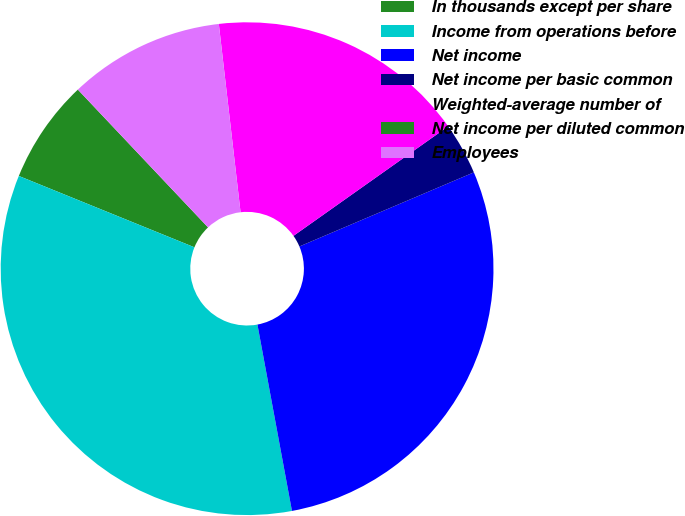<chart> <loc_0><loc_0><loc_500><loc_500><pie_chart><fcel>In thousands except per share<fcel>Income from operations before<fcel>Net income<fcel>Net income per basic common<fcel>Weighted-average number of<fcel>Net income per diluted common<fcel>Employees<nl><fcel>6.81%<fcel>34.06%<fcel>28.48%<fcel>3.41%<fcel>17.03%<fcel>0.0%<fcel>10.22%<nl></chart> 